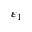Convert formula to latex. <formula><loc_0><loc_0><loc_500><loc_500>\varepsilon _ { 1 }</formula> 